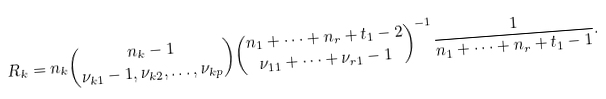Convert formula to latex. <formula><loc_0><loc_0><loc_500><loc_500>R _ { k } = n _ { k } \binom { n _ { k } - 1 } { \nu _ { k 1 } - 1 , \nu _ { k 2 } , \dots , \nu _ { k p } } \binom { n _ { 1 } + \cdots + n _ { r } + t _ { 1 } - 2 } { \nu _ { 1 1 } + \cdots + \nu _ { r 1 } - 1 } ^ { - 1 } \frac { 1 } { n _ { 1 } + \cdots + n _ { r } + t _ { 1 } - 1 } .</formula> 